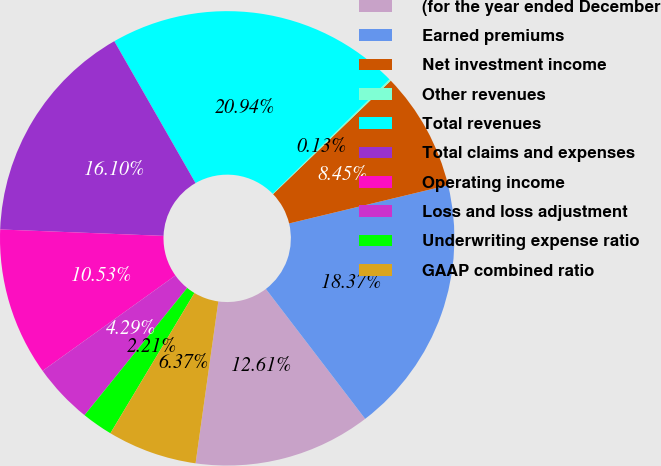Convert chart. <chart><loc_0><loc_0><loc_500><loc_500><pie_chart><fcel>(for the year ended December<fcel>Earned premiums<fcel>Net investment income<fcel>Other revenues<fcel>Total revenues<fcel>Total claims and expenses<fcel>Operating income<fcel>Loss and loss adjustment<fcel>Underwriting expense ratio<fcel>GAAP combined ratio<nl><fcel>12.61%<fcel>18.37%<fcel>8.45%<fcel>0.13%<fcel>20.94%<fcel>16.1%<fcel>10.53%<fcel>4.29%<fcel>2.21%<fcel>6.37%<nl></chart> 